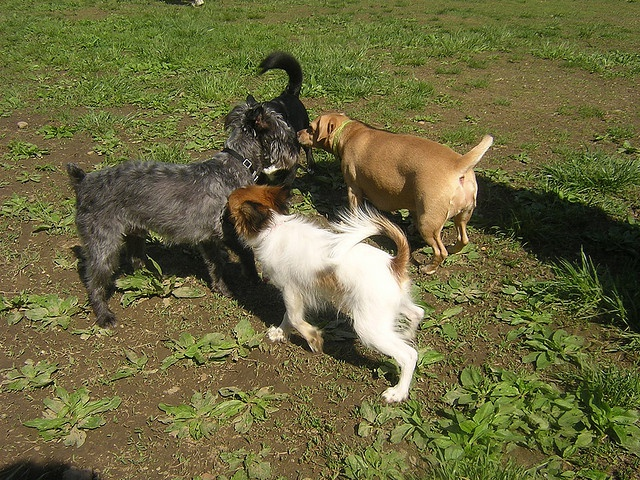Describe the objects in this image and their specific colors. I can see dog in darkgreen, gray, and black tones, dog in darkgreen, ivory, tan, and black tones, dog in darkgreen, olive, and tan tones, and dog in darkgreen, black, and gray tones in this image. 